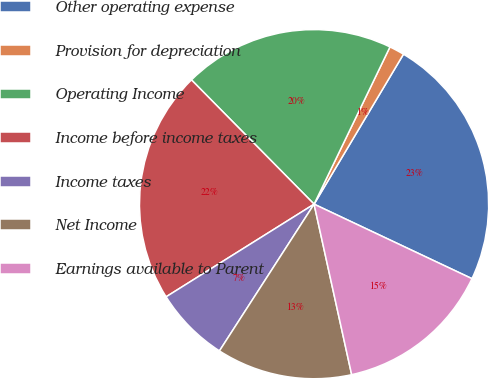Convert chart to OTSL. <chart><loc_0><loc_0><loc_500><loc_500><pie_chart><fcel>Other operating expense<fcel>Provision for depreciation<fcel>Operating Income<fcel>Income before income taxes<fcel>Income taxes<fcel>Net Income<fcel>Earnings available to Parent<nl><fcel>23.46%<fcel>1.4%<fcel>19.55%<fcel>21.51%<fcel>6.98%<fcel>12.57%<fcel>14.53%<nl></chart> 